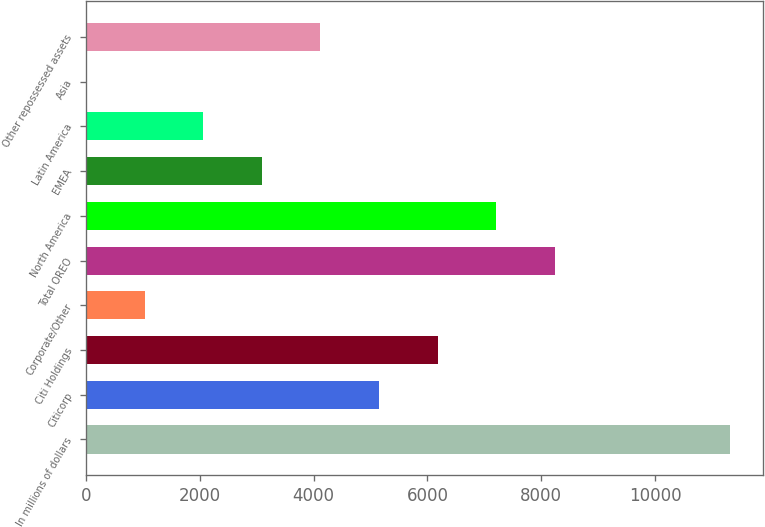Convert chart to OTSL. <chart><loc_0><loc_0><loc_500><loc_500><bar_chart><fcel>In millions of dollars<fcel>Citicorp<fcel>Citi Holdings<fcel>Corporate/Other<fcel>Total OREO<fcel>North America<fcel>EMEA<fcel>Latin America<fcel>Asia<fcel>Other repossessed assets<nl><fcel>11324.2<fcel>5149<fcel>6178.2<fcel>1032.2<fcel>8236.6<fcel>7207.4<fcel>3090.6<fcel>2061.4<fcel>3<fcel>4119.8<nl></chart> 